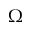Convert formula to latex. <formula><loc_0><loc_0><loc_500><loc_500>\Omega</formula> 